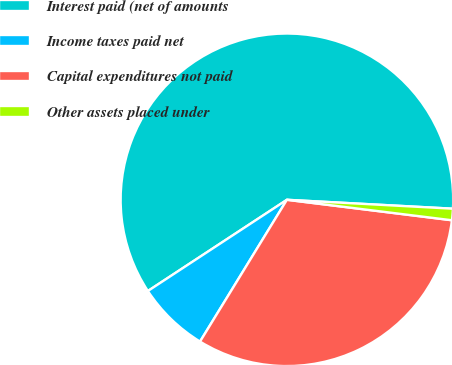Convert chart to OTSL. <chart><loc_0><loc_0><loc_500><loc_500><pie_chart><fcel>Interest paid (net of amounts<fcel>Income taxes paid net<fcel>Capital expenditures not paid<fcel>Other assets placed under<nl><fcel>60.1%<fcel>7.01%<fcel>31.79%<fcel>1.11%<nl></chart> 